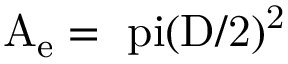<formula> <loc_0><loc_0><loc_500><loc_500>{ A _ { e } } = \ p i ( \mathrm { { D } / 2 ) ^ { 2 } }</formula> 